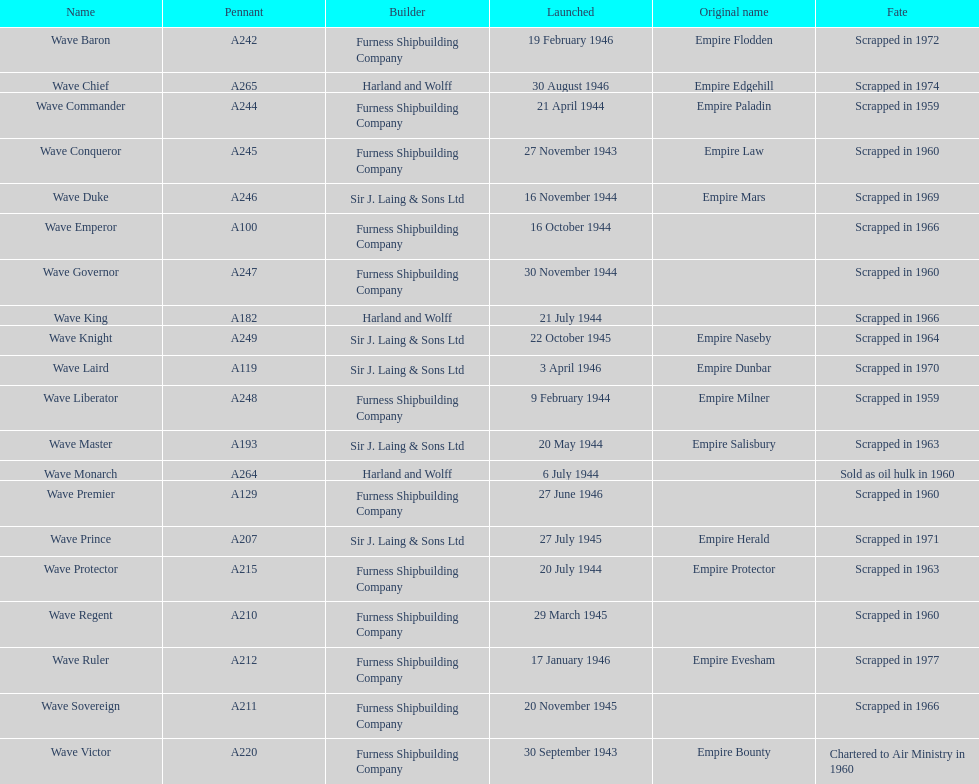How many vessels were launched in the year 1944? 9. 